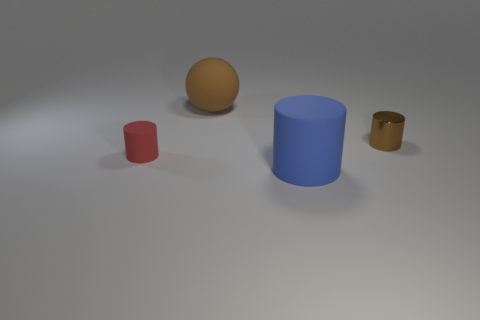Add 3 spheres. How many objects exist? 7 Subtract all brown cylinders. How many cylinders are left? 2 Subtract all red cylinders. Subtract all purple cubes. How many cylinders are left? 2 Subtract all brown balls. How many blue cylinders are left? 1 Subtract all brown matte balls. Subtract all tiny red cylinders. How many objects are left? 2 Add 4 tiny shiny cylinders. How many tiny shiny cylinders are left? 5 Add 3 big red matte objects. How many big red matte objects exist? 3 Subtract all brown cylinders. How many cylinders are left? 2 Subtract 0 cyan balls. How many objects are left? 4 Subtract all spheres. How many objects are left? 3 